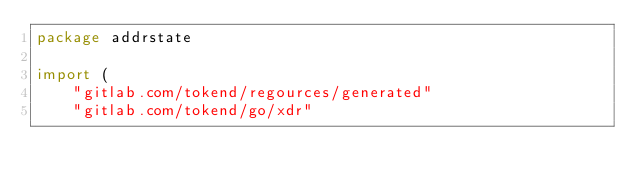Convert code to text. <code><loc_0><loc_0><loc_500><loc_500><_Go_>package addrstate

import (
	"gitlab.com/tokend/regources/generated"
	"gitlab.com/tokend/go/xdr"</code> 